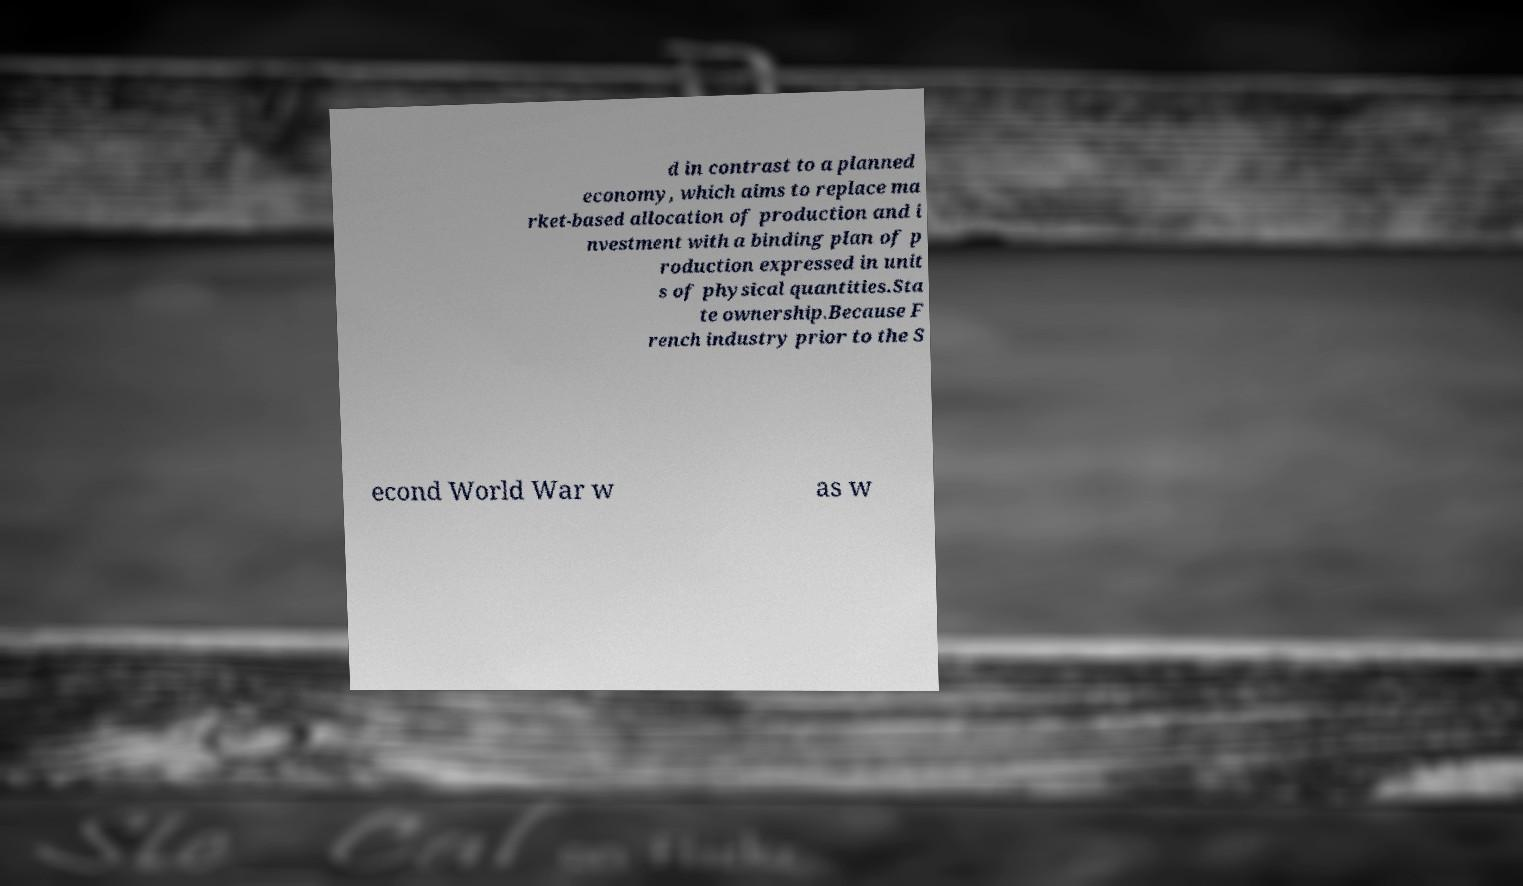Please read and relay the text visible in this image. What does it say? d in contrast to a planned economy, which aims to replace ma rket-based allocation of production and i nvestment with a binding plan of p roduction expressed in unit s of physical quantities.Sta te ownership.Because F rench industry prior to the S econd World War w as w 